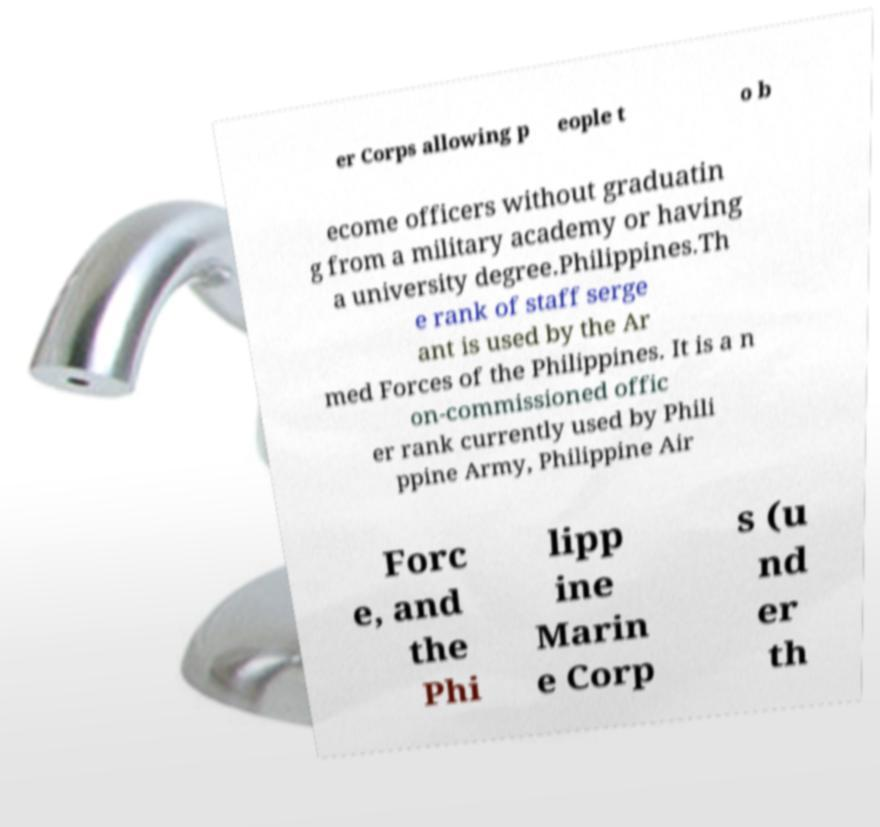Please read and relay the text visible in this image. What does it say? er Corps allowing p eople t o b ecome officers without graduatin g from a military academy or having a university degree.Philippines.Th e rank of staff serge ant is used by the Ar med Forces of the Philippines. It is a n on-commissioned offic er rank currently used by Phili ppine Army, Philippine Air Forc e, and the Phi lipp ine Marin e Corp s (u nd er th 